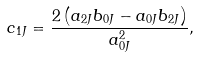<formula> <loc_0><loc_0><loc_500><loc_500>c _ { 1 J } = \frac { 2 \left ( a _ { 2 J } b _ { 0 J } - a _ { 0 J } b _ { 2 J } \right ) } { a _ { 0 J } ^ { 2 } } ,</formula> 